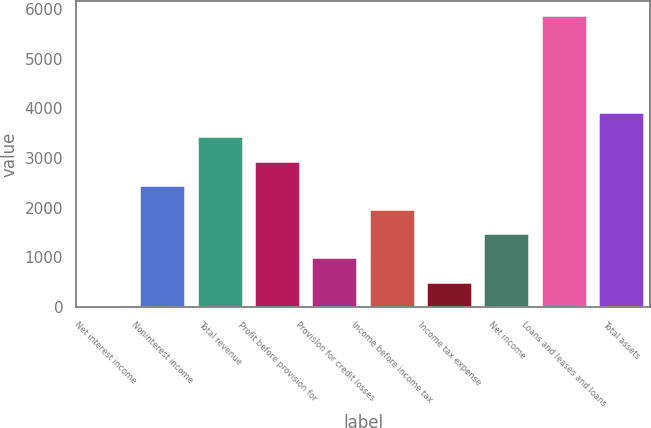Convert chart to OTSL. <chart><loc_0><loc_0><loc_500><loc_500><bar_chart><fcel>Net interest income<fcel>Noninterest income<fcel>Total revenue<fcel>Profit before provision for<fcel>Provision for credit losses<fcel>Income before income tax<fcel>Income tax expense<fcel>Net income<fcel>Loans and leases and loans<fcel>Total assets<nl><fcel>25<fcel>2462.5<fcel>3437.5<fcel>2950<fcel>1000<fcel>1975<fcel>512.5<fcel>1487.5<fcel>5875<fcel>3925<nl></chart> 